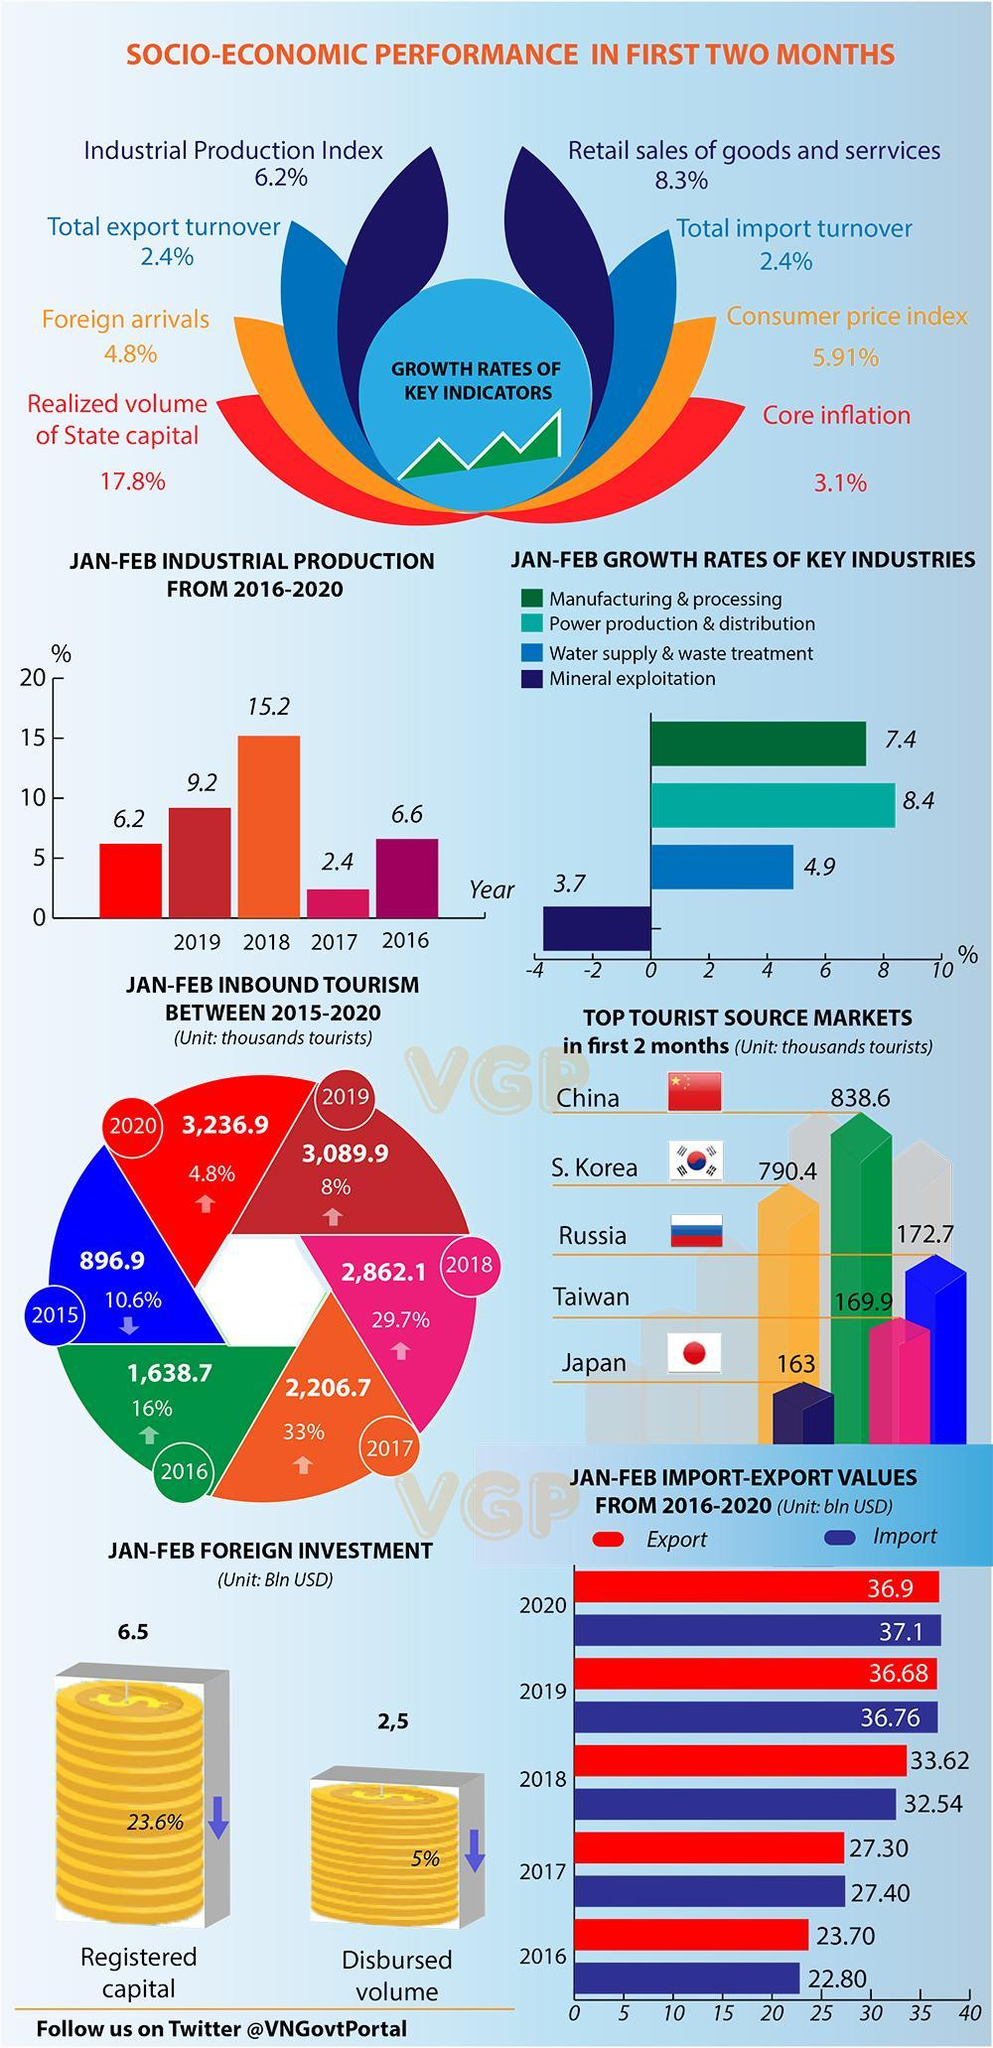In which year the industrial production rate marked the highest in the month of January-February during 2016-2020?
Answer the question with a short phrase. 2018 What is the import value (in billion USD)  in the first two months of 2020? 37.1 What is the export value (in billion USD)  in the first two months of 2019? 36.68 What is the growth rate of manufacturing & processing industry in the first two months during 2016-2020? 7.4 What is the growth rate of water supply & waste treatment industry in the first two months during 2016-2020? 4.9 What is the import value (in billion USD) in the first two months of 2016? 22.80 In which year the industrial production rate marked the lowest in the month of January-February during 2016-2020? 2017 What is the export value (in billion USD) in the first two months of 2018? 33.62 Which industry has showed the lowest growth rate in the first two months during 2016-2020? Mineral exploitation Which industry has showed the highest growth rate in the first two months during 2016-2020? Power production & distribution 